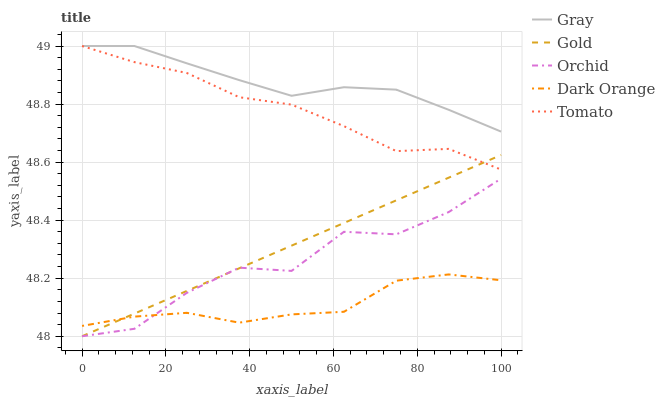Does Dark Orange have the minimum area under the curve?
Answer yes or no. Yes. Does Gray have the maximum area under the curve?
Answer yes or no. Yes. Does Tomato have the minimum area under the curve?
Answer yes or no. No. Does Tomato have the maximum area under the curve?
Answer yes or no. No. Is Gold the smoothest?
Answer yes or no. Yes. Is Orchid the roughest?
Answer yes or no. Yes. Is Gray the smoothest?
Answer yes or no. No. Is Gray the roughest?
Answer yes or no. No. Does Gold have the lowest value?
Answer yes or no. Yes. Does Tomato have the lowest value?
Answer yes or no. No. Does Tomato have the highest value?
Answer yes or no. Yes. Does Gold have the highest value?
Answer yes or no. No. Is Dark Orange less than Tomato?
Answer yes or no. Yes. Is Tomato greater than Orchid?
Answer yes or no. Yes. Does Gold intersect Tomato?
Answer yes or no. Yes. Is Gold less than Tomato?
Answer yes or no. No. Is Gold greater than Tomato?
Answer yes or no. No. Does Dark Orange intersect Tomato?
Answer yes or no. No. 